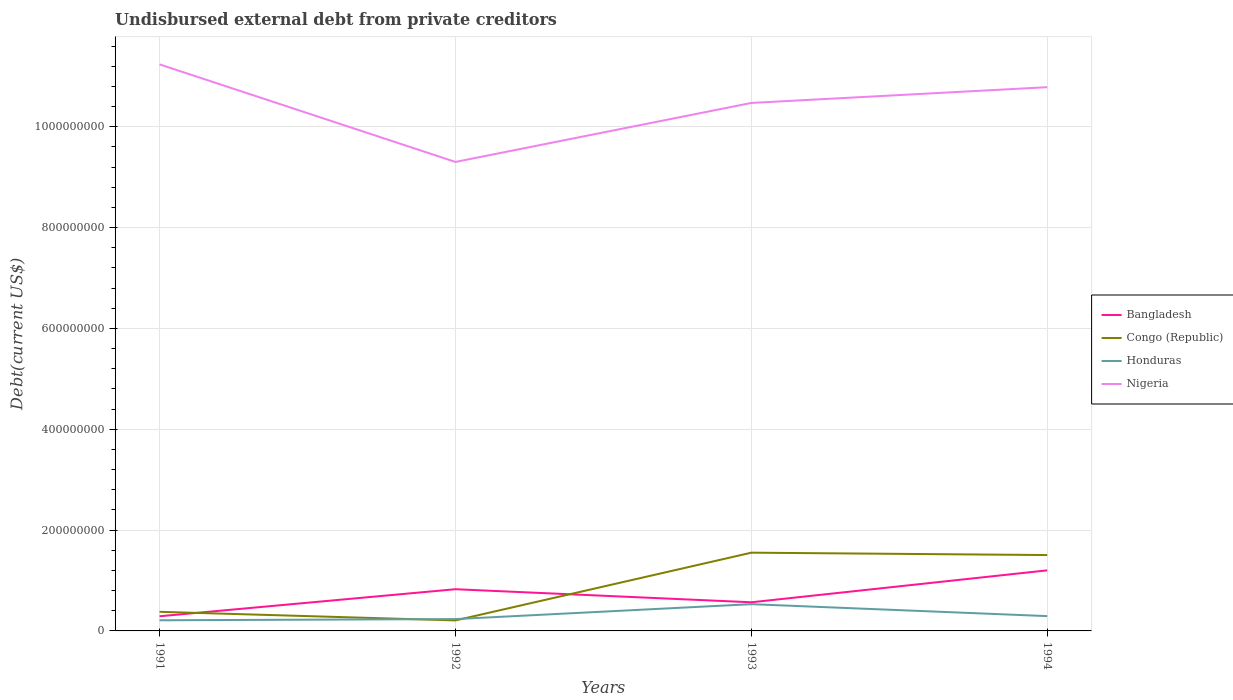How many different coloured lines are there?
Offer a terse response. 4. Is the number of lines equal to the number of legend labels?
Make the answer very short. Yes. Across all years, what is the maximum total debt in Honduras?
Give a very brief answer. 2.11e+07. In which year was the total debt in Congo (Republic) maximum?
Provide a succinct answer. 1992. What is the total total debt in Honduras in the graph?
Ensure brevity in your answer.  -5.92e+06. What is the difference between the highest and the second highest total debt in Bangladesh?
Give a very brief answer. 9.10e+07. How many lines are there?
Your answer should be very brief. 4. Are the values on the major ticks of Y-axis written in scientific E-notation?
Offer a very short reply. No. Does the graph contain grids?
Offer a terse response. Yes. Where does the legend appear in the graph?
Ensure brevity in your answer.  Center right. How are the legend labels stacked?
Your answer should be compact. Vertical. What is the title of the graph?
Give a very brief answer. Undisbursed external debt from private creditors. Does "Bahrain" appear as one of the legend labels in the graph?
Your answer should be very brief. No. What is the label or title of the X-axis?
Keep it short and to the point. Years. What is the label or title of the Y-axis?
Your answer should be very brief. Debt(current US$). What is the Debt(current US$) in Bangladesh in 1991?
Provide a short and direct response. 2.91e+07. What is the Debt(current US$) of Congo (Republic) in 1991?
Make the answer very short. 3.79e+07. What is the Debt(current US$) of Honduras in 1991?
Offer a terse response. 2.11e+07. What is the Debt(current US$) in Nigeria in 1991?
Make the answer very short. 1.12e+09. What is the Debt(current US$) of Bangladesh in 1992?
Your answer should be very brief. 8.27e+07. What is the Debt(current US$) in Congo (Republic) in 1992?
Your answer should be compact. 2.08e+07. What is the Debt(current US$) in Honduras in 1992?
Provide a succinct answer. 2.35e+07. What is the Debt(current US$) of Nigeria in 1992?
Keep it short and to the point. 9.30e+08. What is the Debt(current US$) of Bangladesh in 1993?
Provide a short and direct response. 5.68e+07. What is the Debt(current US$) of Congo (Republic) in 1993?
Your answer should be compact. 1.55e+08. What is the Debt(current US$) of Honduras in 1993?
Make the answer very short. 5.31e+07. What is the Debt(current US$) in Nigeria in 1993?
Your answer should be very brief. 1.05e+09. What is the Debt(current US$) in Bangladesh in 1994?
Provide a short and direct response. 1.20e+08. What is the Debt(current US$) of Congo (Republic) in 1994?
Give a very brief answer. 1.50e+08. What is the Debt(current US$) of Honduras in 1994?
Your response must be concise. 2.94e+07. What is the Debt(current US$) of Nigeria in 1994?
Offer a very short reply. 1.08e+09. Across all years, what is the maximum Debt(current US$) of Bangladesh?
Your response must be concise. 1.20e+08. Across all years, what is the maximum Debt(current US$) in Congo (Republic)?
Provide a succinct answer. 1.55e+08. Across all years, what is the maximum Debt(current US$) of Honduras?
Provide a short and direct response. 5.31e+07. Across all years, what is the maximum Debt(current US$) of Nigeria?
Offer a terse response. 1.12e+09. Across all years, what is the minimum Debt(current US$) in Bangladesh?
Offer a terse response. 2.91e+07. Across all years, what is the minimum Debt(current US$) in Congo (Republic)?
Provide a short and direct response. 2.08e+07. Across all years, what is the minimum Debt(current US$) of Honduras?
Provide a short and direct response. 2.11e+07. Across all years, what is the minimum Debt(current US$) of Nigeria?
Make the answer very short. 9.30e+08. What is the total Debt(current US$) in Bangladesh in the graph?
Provide a short and direct response. 2.89e+08. What is the total Debt(current US$) in Congo (Republic) in the graph?
Offer a terse response. 3.64e+08. What is the total Debt(current US$) of Honduras in the graph?
Offer a terse response. 1.27e+08. What is the total Debt(current US$) in Nigeria in the graph?
Your answer should be compact. 4.18e+09. What is the difference between the Debt(current US$) in Bangladesh in 1991 and that in 1992?
Offer a terse response. -5.36e+07. What is the difference between the Debt(current US$) of Congo (Republic) in 1991 and that in 1992?
Offer a very short reply. 1.71e+07. What is the difference between the Debt(current US$) in Honduras in 1991 and that in 1992?
Give a very brief answer. -2.36e+06. What is the difference between the Debt(current US$) in Nigeria in 1991 and that in 1992?
Offer a terse response. 1.93e+08. What is the difference between the Debt(current US$) of Bangladesh in 1991 and that in 1993?
Ensure brevity in your answer.  -2.77e+07. What is the difference between the Debt(current US$) of Congo (Republic) in 1991 and that in 1993?
Offer a terse response. -1.17e+08. What is the difference between the Debt(current US$) of Honduras in 1991 and that in 1993?
Offer a terse response. -3.19e+07. What is the difference between the Debt(current US$) in Nigeria in 1991 and that in 1993?
Make the answer very short. 7.65e+07. What is the difference between the Debt(current US$) in Bangladesh in 1991 and that in 1994?
Your answer should be very brief. -9.10e+07. What is the difference between the Debt(current US$) of Congo (Republic) in 1991 and that in 1994?
Ensure brevity in your answer.  -1.13e+08. What is the difference between the Debt(current US$) in Honduras in 1991 and that in 1994?
Provide a succinct answer. -8.28e+06. What is the difference between the Debt(current US$) of Nigeria in 1991 and that in 1994?
Your answer should be very brief. 4.52e+07. What is the difference between the Debt(current US$) of Bangladesh in 1992 and that in 1993?
Provide a succinct answer. 2.59e+07. What is the difference between the Debt(current US$) of Congo (Republic) in 1992 and that in 1993?
Your answer should be very brief. -1.34e+08. What is the difference between the Debt(current US$) in Honduras in 1992 and that in 1993?
Keep it short and to the point. -2.96e+07. What is the difference between the Debt(current US$) in Nigeria in 1992 and that in 1993?
Your answer should be compact. -1.17e+08. What is the difference between the Debt(current US$) of Bangladesh in 1992 and that in 1994?
Keep it short and to the point. -3.74e+07. What is the difference between the Debt(current US$) in Congo (Republic) in 1992 and that in 1994?
Offer a very short reply. -1.30e+08. What is the difference between the Debt(current US$) in Honduras in 1992 and that in 1994?
Give a very brief answer. -5.92e+06. What is the difference between the Debt(current US$) in Nigeria in 1992 and that in 1994?
Offer a very short reply. -1.48e+08. What is the difference between the Debt(current US$) of Bangladesh in 1993 and that in 1994?
Your answer should be compact. -6.33e+07. What is the difference between the Debt(current US$) in Congo (Republic) in 1993 and that in 1994?
Provide a succinct answer. 4.70e+06. What is the difference between the Debt(current US$) of Honduras in 1993 and that in 1994?
Offer a terse response. 2.37e+07. What is the difference between the Debt(current US$) of Nigeria in 1993 and that in 1994?
Provide a succinct answer. -3.12e+07. What is the difference between the Debt(current US$) in Bangladesh in 1991 and the Debt(current US$) in Congo (Republic) in 1992?
Keep it short and to the point. 8.23e+06. What is the difference between the Debt(current US$) of Bangladesh in 1991 and the Debt(current US$) of Honduras in 1992?
Your answer should be very brief. 5.60e+06. What is the difference between the Debt(current US$) of Bangladesh in 1991 and the Debt(current US$) of Nigeria in 1992?
Give a very brief answer. -9.01e+08. What is the difference between the Debt(current US$) of Congo (Republic) in 1991 and the Debt(current US$) of Honduras in 1992?
Provide a short and direct response. 1.44e+07. What is the difference between the Debt(current US$) in Congo (Republic) in 1991 and the Debt(current US$) in Nigeria in 1992?
Make the answer very short. -8.92e+08. What is the difference between the Debt(current US$) of Honduras in 1991 and the Debt(current US$) of Nigeria in 1992?
Make the answer very short. -9.09e+08. What is the difference between the Debt(current US$) in Bangladesh in 1991 and the Debt(current US$) in Congo (Republic) in 1993?
Offer a terse response. -1.26e+08. What is the difference between the Debt(current US$) in Bangladesh in 1991 and the Debt(current US$) in Honduras in 1993?
Offer a terse response. -2.40e+07. What is the difference between the Debt(current US$) of Bangladesh in 1991 and the Debt(current US$) of Nigeria in 1993?
Keep it short and to the point. -1.02e+09. What is the difference between the Debt(current US$) of Congo (Republic) in 1991 and the Debt(current US$) of Honduras in 1993?
Offer a terse response. -1.52e+07. What is the difference between the Debt(current US$) of Congo (Republic) in 1991 and the Debt(current US$) of Nigeria in 1993?
Give a very brief answer. -1.01e+09. What is the difference between the Debt(current US$) of Honduras in 1991 and the Debt(current US$) of Nigeria in 1993?
Offer a terse response. -1.03e+09. What is the difference between the Debt(current US$) in Bangladesh in 1991 and the Debt(current US$) in Congo (Republic) in 1994?
Keep it short and to the point. -1.21e+08. What is the difference between the Debt(current US$) of Bangladesh in 1991 and the Debt(current US$) of Honduras in 1994?
Give a very brief answer. -3.15e+05. What is the difference between the Debt(current US$) of Bangladesh in 1991 and the Debt(current US$) of Nigeria in 1994?
Ensure brevity in your answer.  -1.05e+09. What is the difference between the Debt(current US$) in Congo (Republic) in 1991 and the Debt(current US$) in Honduras in 1994?
Provide a succinct answer. 8.51e+06. What is the difference between the Debt(current US$) in Congo (Republic) in 1991 and the Debt(current US$) in Nigeria in 1994?
Your response must be concise. -1.04e+09. What is the difference between the Debt(current US$) of Honduras in 1991 and the Debt(current US$) of Nigeria in 1994?
Keep it short and to the point. -1.06e+09. What is the difference between the Debt(current US$) of Bangladesh in 1992 and the Debt(current US$) of Congo (Republic) in 1993?
Give a very brief answer. -7.25e+07. What is the difference between the Debt(current US$) of Bangladesh in 1992 and the Debt(current US$) of Honduras in 1993?
Give a very brief answer. 2.97e+07. What is the difference between the Debt(current US$) in Bangladesh in 1992 and the Debt(current US$) in Nigeria in 1993?
Your answer should be very brief. -9.64e+08. What is the difference between the Debt(current US$) of Congo (Republic) in 1992 and the Debt(current US$) of Honduras in 1993?
Your response must be concise. -3.22e+07. What is the difference between the Debt(current US$) of Congo (Republic) in 1992 and the Debt(current US$) of Nigeria in 1993?
Provide a short and direct response. -1.03e+09. What is the difference between the Debt(current US$) of Honduras in 1992 and the Debt(current US$) of Nigeria in 1993?
Offer a terse response. -1.02e+09. What is the difference between the Debt(current US$) in Bangladesh in 1992 and the Debt(current US$) in Congo (Republic) in 1994?
Ensure brevity in your answer.  -6.78e+07. What is the difference between the Debt(current US$) of Bangladesh in 1992 and the Debt(current US$) of Honduras in 1994?
Keep it short and to the point. 5.33e+07. What is the difference between the Debt(current US$) in Bangladesh in 1992 and the Debt(current US$) in Nigeria in 1994?
Give a very brief answer. -9.96e+08. What is the difference between the Debt(current US$) of Congo (Republic) in 1992 and the Debt(current US$) of Honduras in 1994?
Make the answer very short. -8.54e+06. What is the difference between the Debt(current US$) in Congo (Republic) in 1992 and the Debt(current US$) in Nigeria in 1994?
Provide a short and direct response. -1.06e+09. What is the difference between the Debt(current US$) in Honduras in 1992 and the Debt(current US$) in Nigeria in 1994?
Keep it short and to the point. -1.05e+09. What is the difference between the Debt(current US$) of Bangladesh in 1993 and the Debt(current US$) of Congo (Republic) in 1994?
Make the answer very short. -9.37e+07. What is the difference between the Debt(current US$) of Bangladesh in 1993 and the Debt(current US$) of Honduras in 1994?
Offer a very short reply. 2.74e+07. What is the difference between the Debt(current US$) in Bangladesh in 1993 and the Debt(current US$) in Nigeria in 1994?
Your response must be concise. -1.02e+09. What is the difference between the Debt(current US$) of Congo (Republic) in 1993 and the Debt(current US$) of Honduras in 1994?
Give a very brief answer. 1.26e+08. What is the difference between the Debt(current US$) of Congo (Republic) in 1993 and the Debt(current US$) of Nigeria in 1994?
Offer a very short reply. -9.23e+08. What is the difference between the Debt(current US$) in Honduras in 1993 and the Debt(current US$) in Nigeria in 1994?
Keep it short and to the point. -1.03e+09. What is the average Debt(current US$) of Bangladesh per year?
Ensure brevity in your answer.  7.22e+07. What is the average Debt(current US$) in Congo (Republic) per year?
Your response must be concise. 9.11e+07. What is the average Debt(current US$) of Honduras per year?
Offer a very short reply. 3.18e+07. What is the average Debt(current US$) in Nigeria per year?
Your answer should be compact. 1.04e+09. In the year 1991, what is the difference between the Debt(current US$) in Bangladesh and Debt(current US$) in Congo (Republic)?
Your answer should be compact. -8.83e+06. In the year 1991, what is the difference between the Debt(current US$) in Bangladesh and Debt(current US$) in Honduras?
Your answer should be very brief. 7.96e+06. In the year 1991, what is the difference between the Debt(current US$) of Bangladesh and Debt(current US$) of Nigeria?
Your response must be concise. -1.09e+09. In the year 1991, what is the difference between the Debt(current US$) of Congo (Republic) and Debt(current US$) of Honduras?
Give a very brief answer. 1.68e+07. In the year 1991, what is the difference between the Debt(current US$) in Congo (Republic) and Debt(current US$) in Nigeria?
Your answer should be very brief. -1.09e+09. In the year 1991, what is the difference between the Debt(current US$) of Honduras and Debt(current US$) of Nigeria?
Offer a terse response. -1.10e+09. In the year 1992, what is the difference between the Debt(current US$) in Bangladesh and Debt(current US$) in Congo (Republic)?
Offer a very short reply. 6.19e+07. In the year 1992, what is the difference between the Debt(current US$) in Bangladesh and Debt(current US$) in Honduras?
Make the answer very short. 5.92e+07. In the year 1992, what is the difference between the Debt(current US$) of Bangladesh and Debt(current US$) of Nigeria?
Give a very brief answer. -8.47e+08. In the year 1992, what is the difference between the Debt(current US$) in Congo (Republic) and Debt(current US$) in Honduras?
Provide a short and direct response. -2.63e+06. In the year 1992, what is the difference between the Debt(current US$) in Congo (Republic) and Debt(current US$) in Nigeria?
Your answer should be compact. -9.09e+08. In the year 1992, what is the difference between the Debt(current US$) of Honduras and Debt(current US$) of Nigeria?
Keep it short and to the point. -9.07e+08. In the year 1993, what is the difference between the Debt(current US$) in Bangladesh and Debt(current US$) in Congo (Republic)?
Keep it short and to the point. -9.84e+07. In the year 1993, what is the difference between the Debt(current US$) in Bangladesh and Debt(current US$) in Honduras?
Ensure brevity in your answer.  3.74e+06. In the year 1993, what is the difference between the Debt(current US$) in Bangladesh and Debt(current US$) in Nigeria?
Offer a very short reply. -9.90e+08. In the year 1993, what is the difference between the Debt(current US$) of Congo (Republic) and Debt(current US$) of Honduras?
Keep it short and to the point. 1.02e+08. In the year 1993, what is the difference between the Debt(current US$) in Congo (Republic) and Debt(current US$) in Nigeria?
Your answer should be very brief. -8.92e+08. In the year 1993, what is the difference between the Debt(current US$) of Honduras and Debt(current US$) of Nigeria?
Offer a terse response. -9.94e+08. In the year 1994, what is the difference between the Debt(current US$) of Bangladesh and Debt(current US$) of Congo (Republic)?
Your response must be concise. -3.04e+07. In the year 1994, what is the difference between the Debt(current US$) in Bangladesh and Debt(current US$) in Honduras?
Your answer should be very brief. 9.07e+07. In the year 1994, what is the difference between the Debt(current US$) in Bangladesh and Debt(current US$) in Nigeria?
Your response must be concise. -9.58e+08. In the year 1994, what is the difference between the Debt(current US$) in Congo (Republic) and Debt(current US$) in Honduras?
Offer a terse response. 1.21e+08. In the year 1994, what is the difference between the Debt(current US$) in Congo (Republic) and Debt(current US$) in Nigeria?
Provide a short and direct response. -9.28e+08. In the year 1994, what is the difference between the Debt(current US$) in Honduras and Debt(current US$) in Nigeria?
Provide a short and direct response. -1.05e+09. What is the ratio of the Debt(current US$) in Bangladesh in 1991 to that in 1992?
Your answer should be very brief. 0.35. What is the ratio of the Debt(current US$) in Congo (Republic) in 1991 to that in 1992?
Your response must be concise. 1.82. What is the ratio of the Debt(current US$) of Honduras in 1991 to that in 1992?
Keep it short and to the point. 0.9. What is the ratio of the Debt(current US$) in Nigeria in 1991 to that in 1992?
Provide a succinct answer. 1.21. What is the ratio of the Debt(current US$) in Bangladesh in 1991 to that in 1993?
Provide a short and direct response. 0.51. What is the ratio of the Debt(current US$) in Congo (Republic) in 1991 to that in 1993?
Offer a terse response. 0.24. What is the ratio of the Debt(current US$) in Honduras in 1991 to that in 1993?
Your answer should be compact. 0.4. What is the ratio of the Debt(current US$) of Nigeria in 1991 to that in 1993?
Provide a succinct answer. 1.07. What is the ratio of the Debt(current US$) of Bangladesh in 1991 to that in 1994?
Provide a succinct answer. 0.24. What is the ratio of the Debt(current US$) in Congo (Republic) in 1991 to that in 1994?
Give a very brief answer. 0.25. What is the ratio of the Debt(current US$) of Honduras in 1991 to that in 1994?
Provide a succinct answer. 0.72. What is the ratio of the Debt(current US$) in Nigeria in 1991 to that in 1994?
Your answer should be compact. 1.04. What is the ratio of the Debt(current US$) in Bangladesh in 1992 to that in 1993?
Your response must be concise. 1.46. What is the ratio of the Debt(current US$) in Congo (Republic) in 1992 to that in 1993?
Give a very brief answer. 0.13. What is the ratio of the Debt(current US$) of Honduras in 1992 to that in 1993?
Your answer should be very brief. 0.44. What is the ratio of the Debt(current US$) in Nigeria in 1992 to that in 1993?
Give a very brief answer. 0.89. What is the ratio of the Debt(current US$) in Bangladesh in 1992 to that in 1994?
Offer a terse response. 0.69. What is the ratio of the Debt(current US$) of Congo (Republic) in 1992 to that in 1994?
Keep it short and to the point. 0.14. What is the ratio of the Debt(current US$) in Honduras in 1992 to that in 1994?
Your answer should be compact. 0.8. What is the ratio of the Debt(current US$) of Nigeria in 1992 to that in 1994?
Provide a succinct answer. 0.86. What is the ratio of the Debt(current US$) in Bangladesh in 1993 to that in 1994?
Your answer should be very brief. 0.47. What is the ratio of the Debt(current US$) in Congo (Republic) in 1993 to that in 1994?
Your answer should be compact. 1.03. What is the ratio of the Debt(current US$) of Honduras in 1993 to that in 1994?
Keep it short and to the point. 1.81. What is the ratio of the Debt(current US$) in Nigeria in 1993 to that in 1994?
Your response must be concise. 0.97. What is the difference between the highest and the second highest Debt(current US$) in Bangladesh?
Keep it short and to the point. 3.74e+07. What is the difference between the highest and the second highest Debt(current US$) of Congo (Republic)?
Provide a short and direct response. 4.70e+06. What is the difference between the highest and the second highest Debt(current US$) in Honduras?
Offer a terse response. 2.37e+07. What is the difference between the highest and the second highest Debt(current US$) in Nigeria?
Keep it short and to the point. 4.52e+07. What is the difference between the highest and the lowest Debt(current US$) of Bangladesh?
Offer a terse response. 9.10e+07. What is the difference between the highest and the lowest Debt(current US$) in Congo (Republic)?
Offer a very short reply. 1.34e+08. What is the difference between the highest and the lowest Debt(current US$) in Honduras?
Offer a terse response. 3.19e+07. What is the difference between the highest and the lowest Debt(current US$) in Nigeria?
Provide a succinct answer. 1.93e+08. 